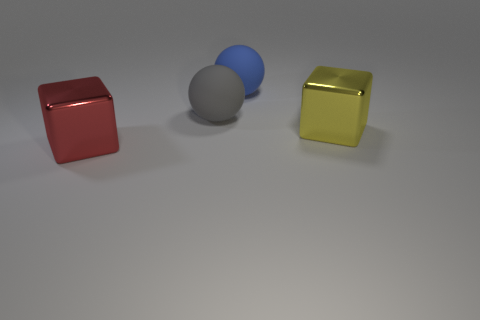Add 4 small blue shiny blocks. How many objects exist? 8 Add 4 big spheres. How many big spheres exist? 6 Subtract 0 gray cubes. How many objects are left? 4 Subtract all gray objects. Subtract all big yellow objects. How many objects are left? 2 Add 4 red metallic cubes. How many red metallic cubes are left? 5 